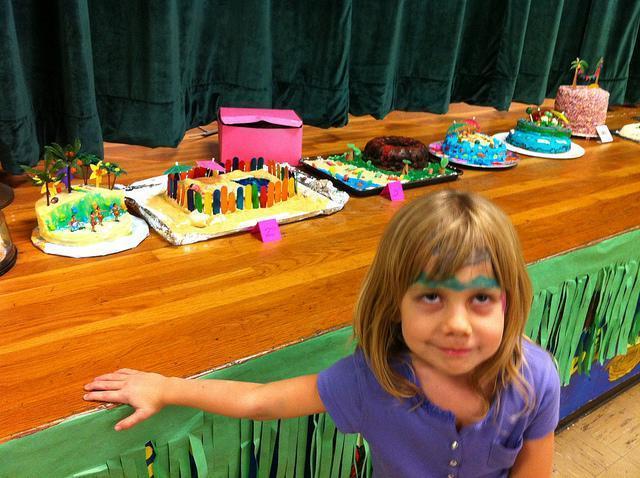Does the caption "The donut is behind the person." correctly depict the image?
Answer yes or no. Yes. 